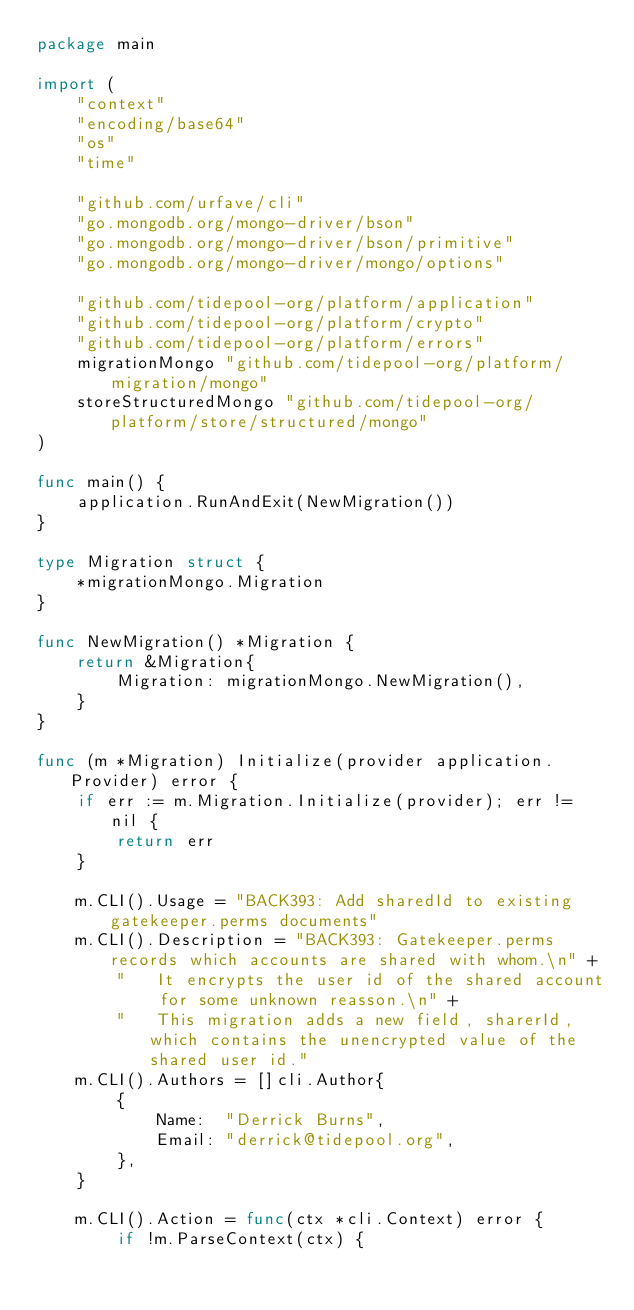Convert code to text. <code><loc_0><loc_0><loc_500><loc_500><_Go_>package main

import (
	"context"
	"encoding/base64"
	"os"
	"time"

	"github.com/urfave/cli"
	"go.mongodb.org/mongo-driver/bson"
	"go.mongodb.org/mongo-driver/bson/primitive"
	"go.mongodb.org/mongo-driver/mongo/options"

	"github.com/tidepool-org/platform/application"
	"github.com/tidepool-org/platform/crypto"
	"github.com/tidepool-org/platform/errors"
	migrationMongo "github.com/tidepool-org/platform/migration/mongo"
	storeStructuredMongo "github.com/tidepool-org/platform/store/structured/mongo"
)

func main() {
	application.RunAndExit(NewMigration())
}

type Migration struct {
	*migrationMongo.Migration
}

func NewMigration() *Migration {
	return &Migration{
		Migration: migrationMongo.NewMigration(),
	}
}

func (m *Migration) Initialize(provider application.Provider) error {
	if err := m.Migration.Initialize(provider); err != nil {
		return err
	}

	m.CLI().Usage = "BACK393: Add sharedId to existing gatekeeper.perms documents"
	m.CLI().Description = "BACK393: Gatekeeper.perms records which accounts are shared with whom.\n" +
		"   It encrypts the user id of the shared account for some unknown reasson.\n" +
		"   This migration adds a new field, sharerId, which contains the unencrypted value of the shared user id."
	m.CLI().Authors = []cli.Author{
		{
			Name:  "Derrick Burns",
			Email: "derrick@tidepool.org",
		},
	}

	m.CLI().Action = func(ctx *cli.Context) error {
		if !m.ParseContext(ctx) {</code> 